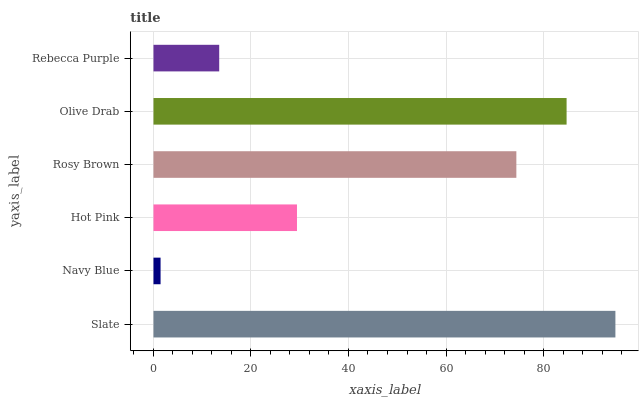Is Navy Blue the minimum?
Answer yes or no. Yes. Is Slate the maximum?
Answer yes or no. Yes. Is Hot Pink the minimum?
Answer yes or no. No. Is Hot Pink the maximum?
Answer yes or no. No. Is Hot Pink greater than Navy Blue?
Answer yes or no. Yes. Is Navy Blue less than Hot Pink?
Answer yes or no. Yes. Is Navy Blue greater than Hot Pink?
Answer yes or no. No. Is Hot Pink less than Navy Blue?
Answer yes or no. No. Is Rosy Brown the high median?
Answer yes or no. Yes. Is Hot Pink the low median?
Answer yes or no. Yes. Is Slate the high median?
Answer yes or no. No. Is Navy Blue the low median?
Answer yes or no. No. 